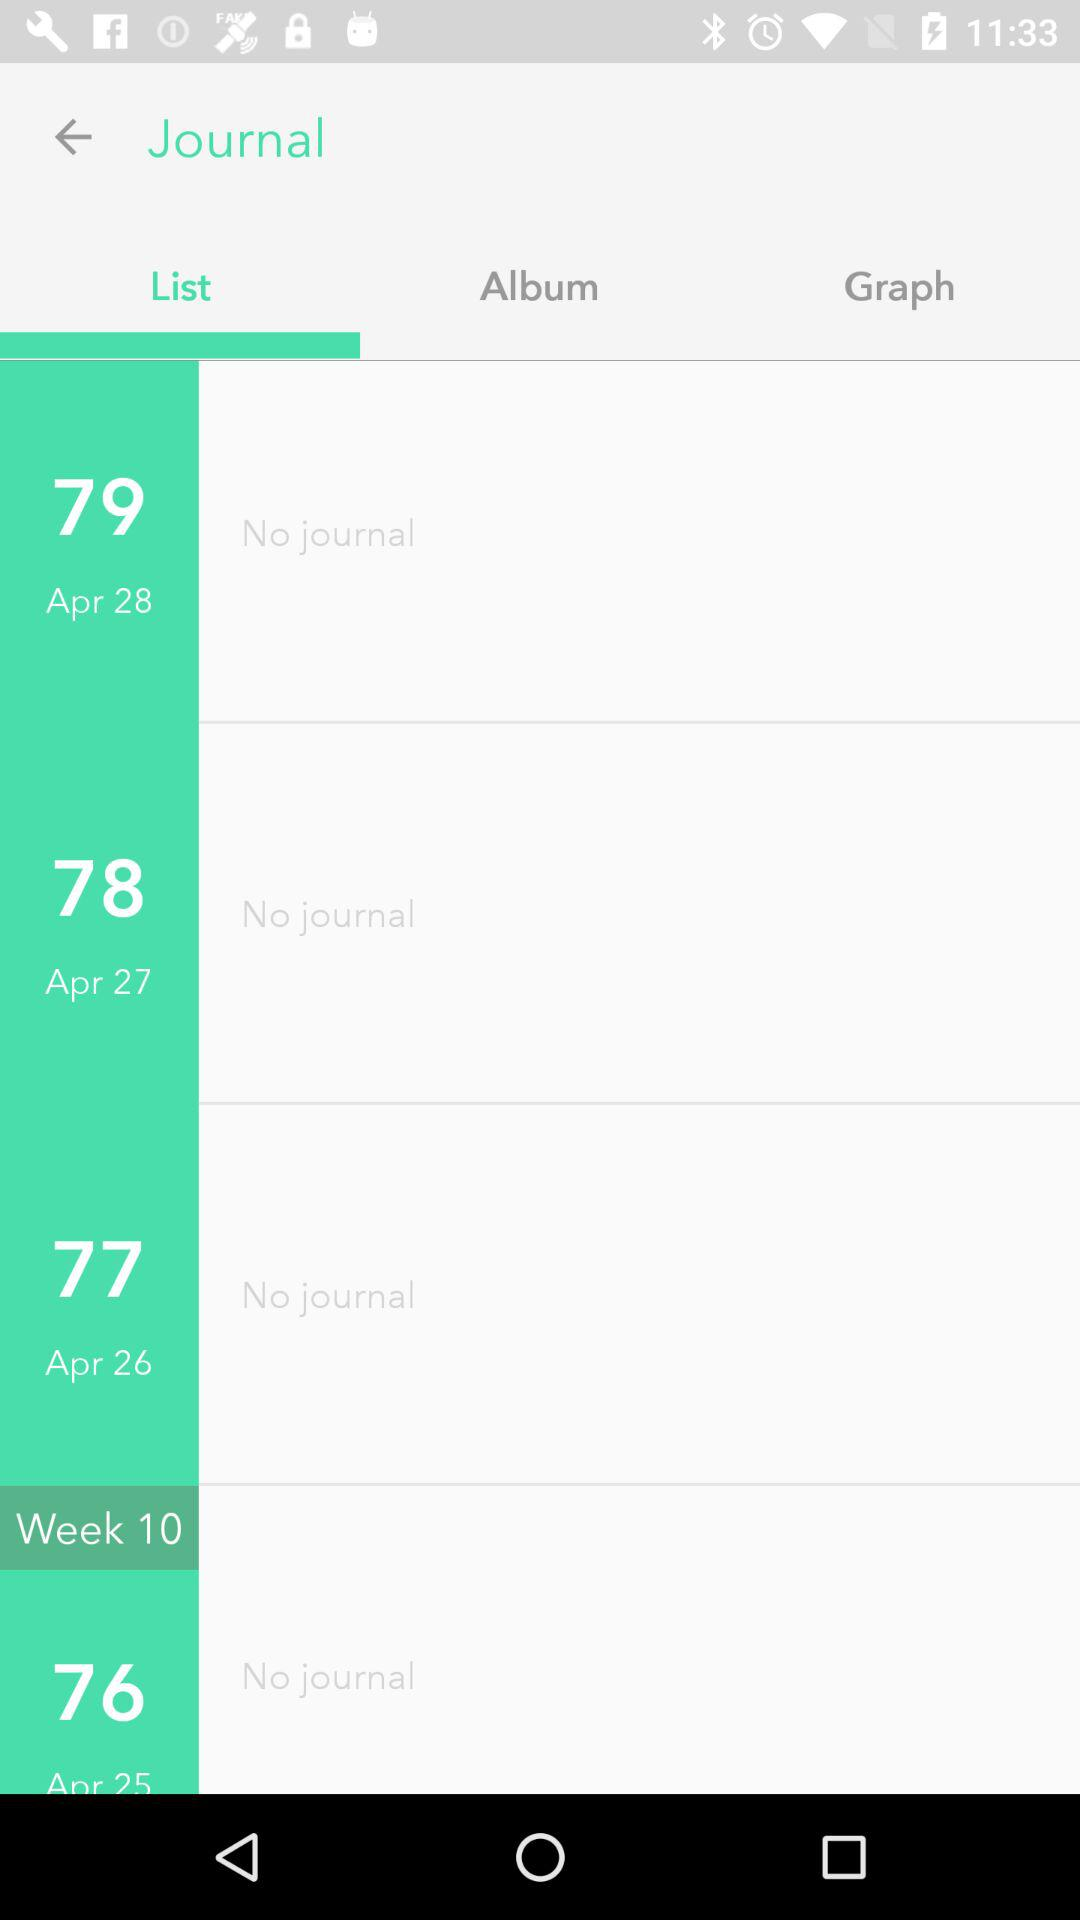Is there any journal on April 27? There is no journal on April 27. 